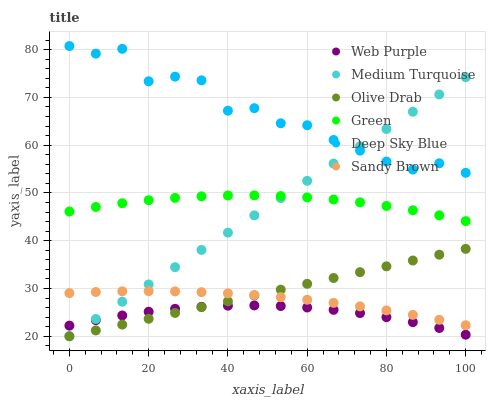Does Web Purple have the minimum area under the curve?
Answer yes or no. Yes. Does Deep Sky Blue have the maximum area under the curve?
Answer yes or no. Yes. Does Green have the minimum area under the curve?
Answer yes or no. No. Does Green have the maximum area under the curve?
Answer yes or no. No. Is Olive Drab the smoothest?
Answer yes or no. Yes. Is Deep Sky Blue the roughest?
Answer yes or no. Yes. Is Web Purple the smoothest?
Answer yes or no. No. Is Web Purple the roughest?
Answer yes or no. No. Does Medium Turquoise have the lowest value?
Answer yes or no. Yes. Does Web Purple have the lowest value?
Answer yes or no. No. Does Deep Sky Blue have the highest value?
Answer yes or no. Yes. Does Green have the highest value?
Answer yes or no. No. Is Green less than Deep Sky Blue?
Answer yes or no. Yes. Is Deep Sky Blue greater than Web Purple?
Answer yes or no. Yes. Does Olive Drab intersect Web Purple?
Answer yes or no. Yes. Is Olive Drab less than Web Purple?
Answer yes or no. No. Is Olive Drab greater than Web Purple?
Answer yes or no. No. Does Green intersect Deep Sky Blue?
Answer yes or no. No. 